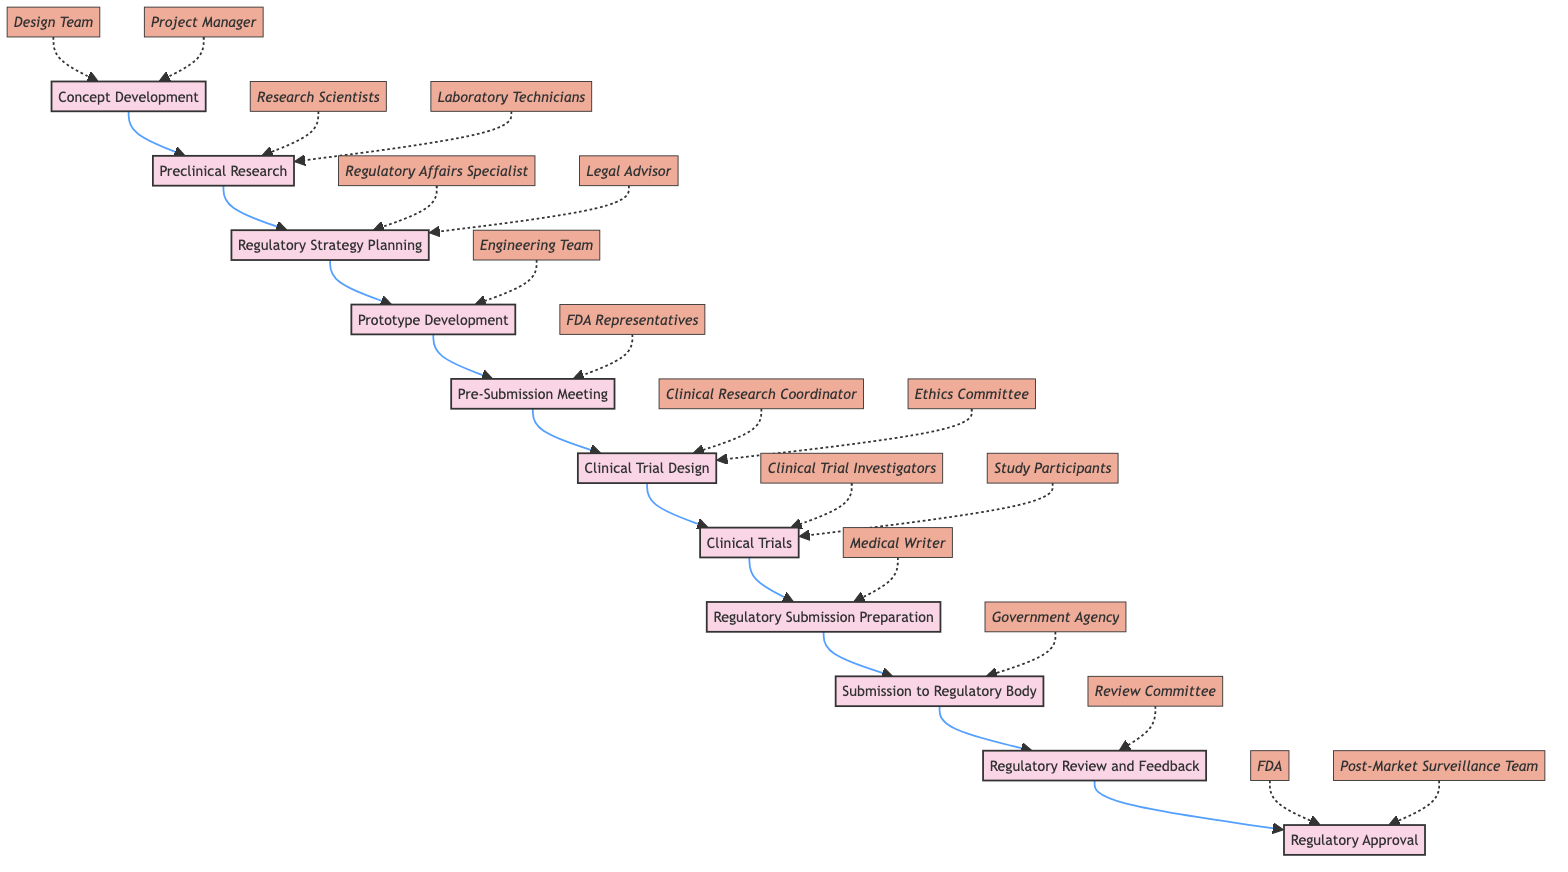What is the first step in the clinical pathway? The first step is "Concept Development" as indicated at the beginning of the flowchart, showing the starting point of the process.
Answer: Concept Development How many steps are in the clinical pathway? By counting the nodes labeled with steps in the diagram, there are a total of 11 steps from the start to regulatory approval.
Answer: 11 Which step immediately follows "Prototype Development"? The flowchart shows that the step following "Prototype Development" is "Pre-Submission Meeting," as indicated by the directed arrow leading from D to E.
Answer: Pre-Submission Meeting Who is involved in "Regulatory Strategy Planning"? The involved entities are "Regulatory Affairs Specialist" and "Legal Advisor," as shown in the diagram next to the "Regulatory Strategy Planning" step.
Answer: Regulatory Affairs Specialist, Legal Advisor What is the last step before obtaining regulatory approval? The step immediately before "Regulatory Approval" is "Regulatory Review and Feedback," which is indicated in the diagram as the penultimate step.
Answer: Regulatory Review and Feedback Which role is responsible for the "Clinical Trials" step? The entities listed as responsible include "Clinical Trial Investigators" and "Study Participants," illustrating their involvement in this crucial stage of the pathway.
Answer: Clinical Trial Investigators, Study Participants What is the relationship between "Regulatory Submission Preparation" and "Submission to Regulatory Body"? The relationship is sequential; “Regulatory Submission Preparation” must be completed before proceeding to “Submission to Regulatory Body,” as indicated by the directed edge in the flowchart.
Answer: Sequential How many key entities are involved in the "Clinical Trial Design" step? The diagram indicates that two key entities are involved in this step: "Clinical Research Coordinator" and "Ethics Committee," which are both clearly labeled in association with the step.
Answer: 2 What role does the "Post-Market Surveillance Team" play in the pathway? This team is involved after receiving "Regulatory Approval" to ensure ongoing compliance and safety post-market, as shown at the end of the pathway.
Answer: Ensure compliance with post-market surveillance 